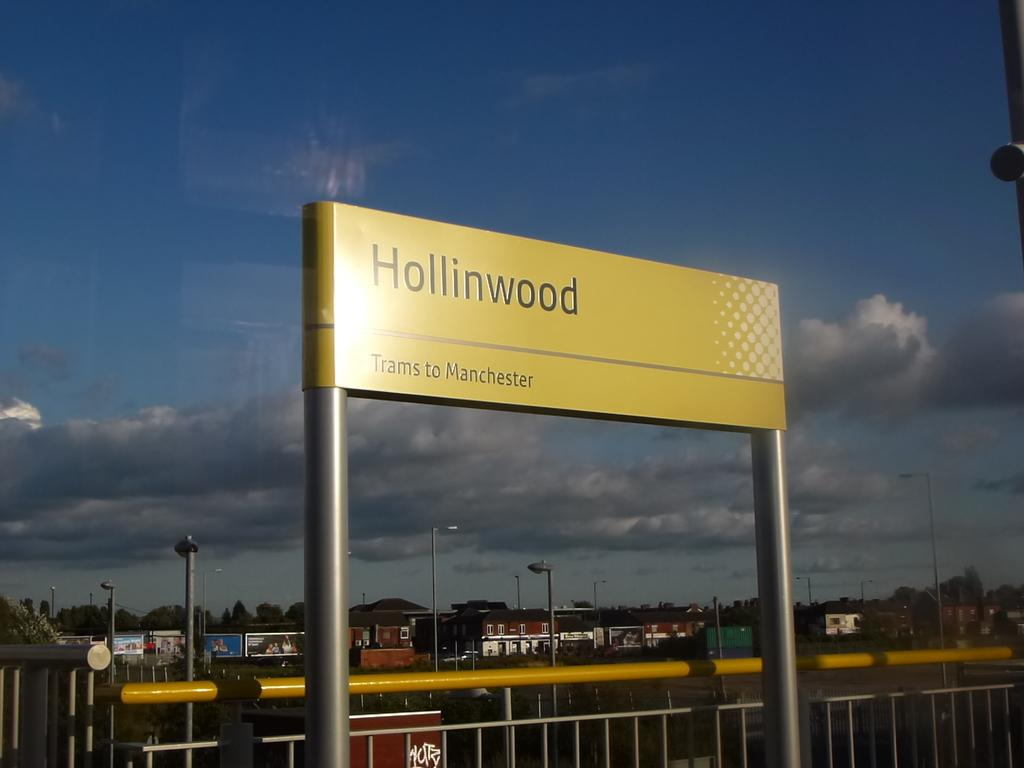Provide a one-sentence caption for the provided image. a street sign with the word Hollinwood written across. 